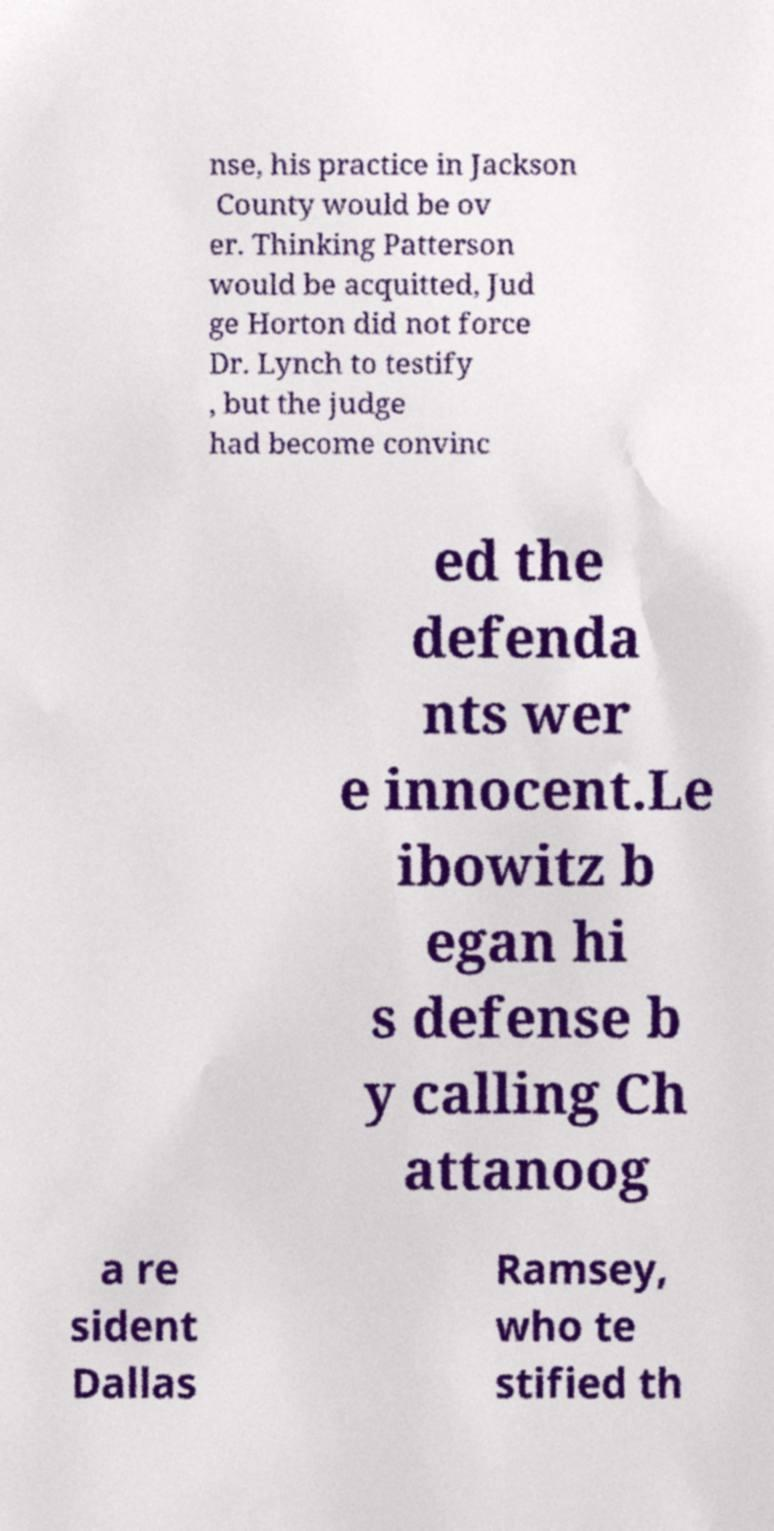For documentation purposes, I need the text within this image transcribed. Could you provide that? nse, his practice in Jackson County would be ov er. Thinking Patterson would be acquitted, Jud ge Horton did not force Dr. Lynch to testify , but the judge had become convinc ed the defenda nts wer e innocent.Le ibowitz b egan hi s defense b y calling Ch attanoog a re sident Dallas Ramsey, who te stified th 